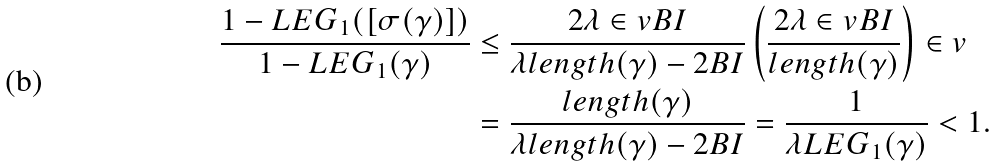Convert formula to latex. <formula><loc_0><loc_0><loc_500><loc_500>\frac { 1 - L E G _ { 1 } ( [ \sigma ( \gamma ) ] ) } { 1 - L E G _ { 1 } ( \gamma ) } & \leq \frac { 2 \lambda \in v B I } { \lambda l e n g t h ( \gamma ) - 2 B I } \left ( \frac { 2 \lambda \in v B I } { l e n g t h ( \gamma ) } \right ) \in v \\ & = \frac { l e n g t h ( \gamma ) } { \lambda l e n g t h ( \gamma ) - 2 B I } = \frac { 1 } { \lambda L E G _ { 1 } ( \gamma ) } < 1 .</formula> 